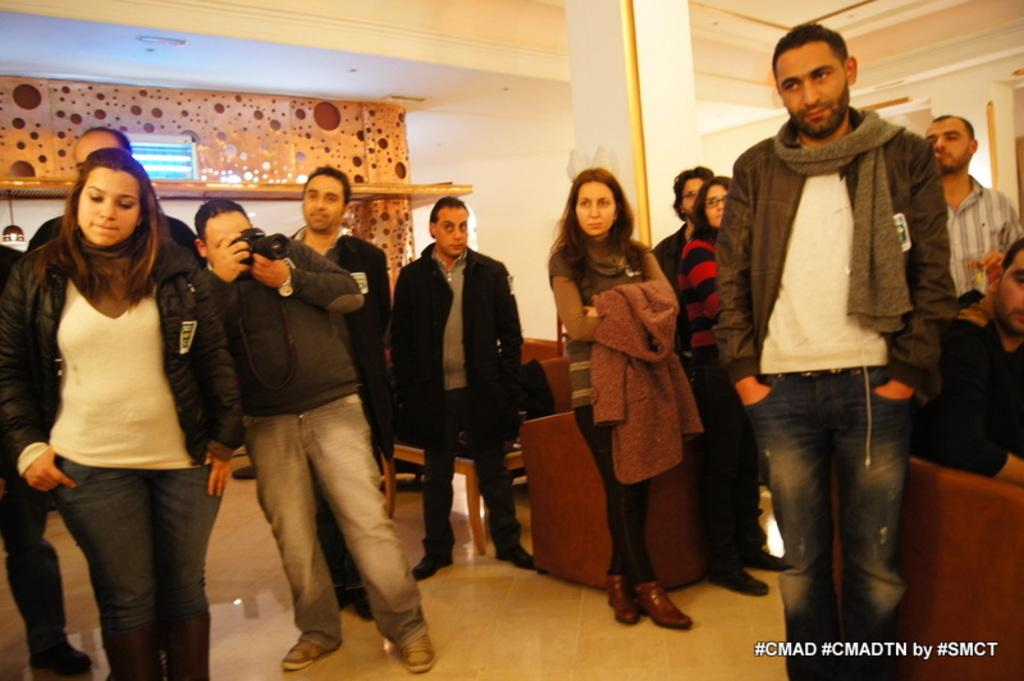What can be observed about the people in the image? There are people standing in the image. Where are the people standing? The people are standing on the floor. What is the man holding in his hand? The man is holding a camera in his hand. What is the woman holding in her hand? The woman is holding a jacket in her hand. What type of cloth is being used to take the breath in the image? There is no cloth or breath present in the image. How many folds can be seen in the jacket held by the woman? The image does not show any folds in the jacket held by the woman, as it only shows the woman holding the jacket. 